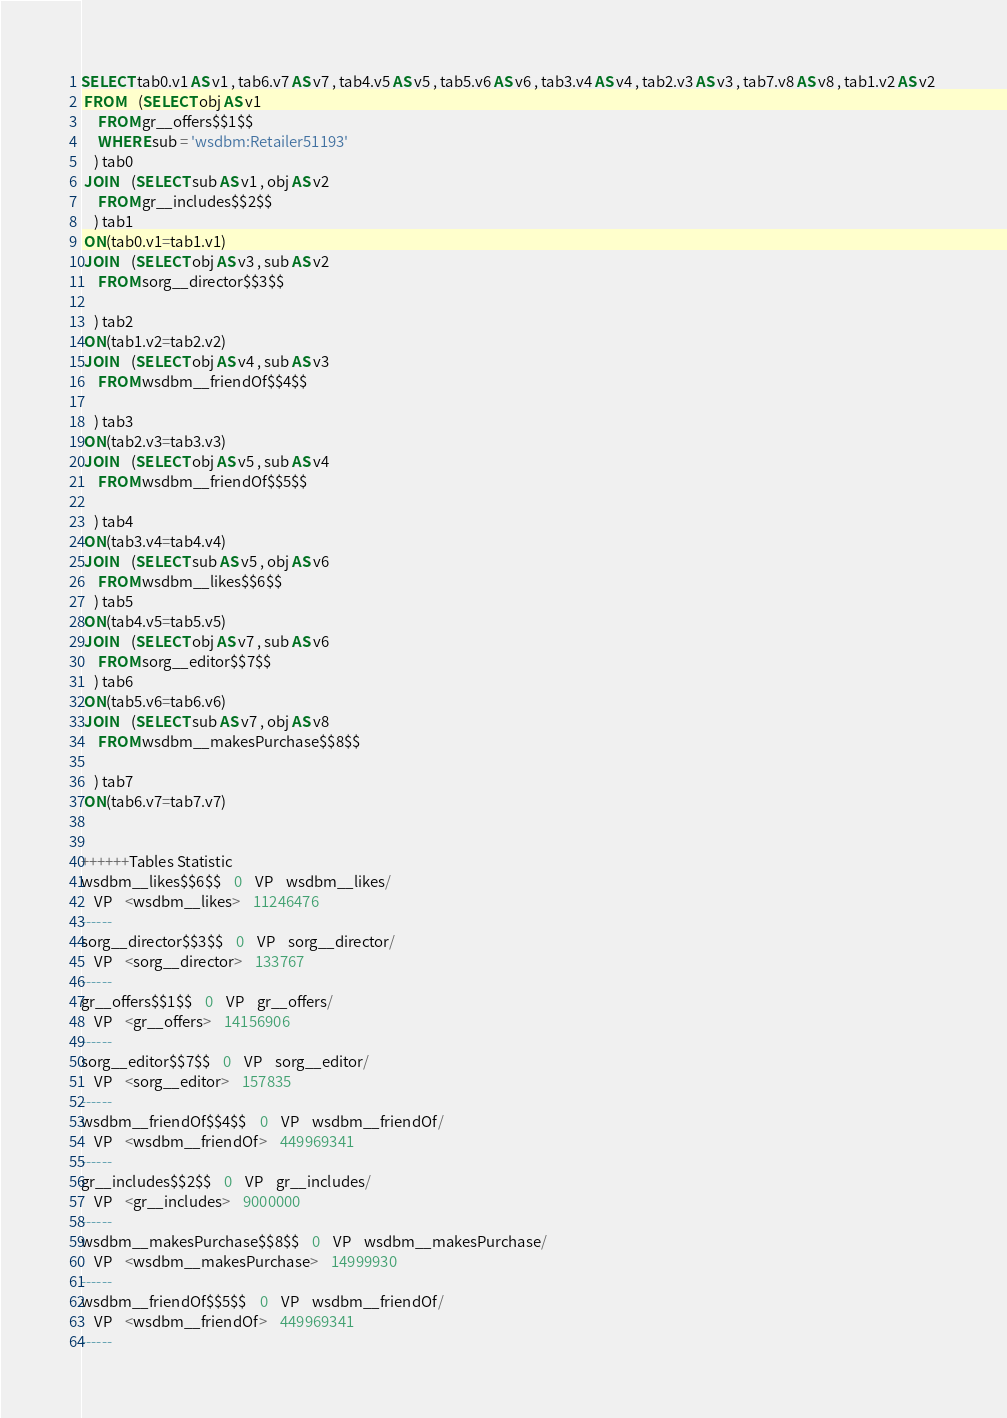<code> <loc_0><loc_0><loc_500><loc_500><_SQL_>SELECT tab0.v1 AS v1 , tab6.v7 AS v7 , tab4.v5 AS v5 , tab5.v6 AS v6 , tab3.v4 AS v4 , tab2.v3 AS v3 , tab7.v8 AS v8 , tab1.v2 AS v2 
 FROM    (SELECT obj AS v1 
	 FROM gr__offers$$1$$ 
	 WHERE sub = 'wsdbm:Retailer51193'
	) tab0
 JOIN    (SELECT sub AS v1 , obj AS v2 
	 FROM gr__includes$$2$$
	) tab1
 ON(tab0.v1=tab1.v1)
 JOIN    (SELECT obj AS v3 , sub AS v2 
	 FROM sorg__director$$3$$
	
	) tab2
 ON(tab1.v2=tab2.v2)
 JOIN    (SELECT obj AS v4 , sub AS v3 
	 FROM wsdbm__friendOf$$4$$
	
	) tab3
 ON(tab2.v3=tab3.v3)
 JOIN    (SELECT obj AS v5 , sub AS v4 
	 FROM wsdbm__friendOf$$5$$
	
	) tab4
 ON(tab3.v4=tab4.v4)
 JOIN    (SELECT sub AS v5 , obj AS v6 
	 FROM wsdbm__likes$$6$$
	) tab5
 ON(tab4.v5=tab5.v5)
 JOIN    (SELECT obj AS v7 , sub AS v6 
	 FROM sorg__editor$$7$$
	) tab6
 ON(tab5.v6=tab6.v6)
 JOIN    (SELECT sub AS v7 , obj AS v8 
	 FROM wsdbm__makesPurchase$$8$$
	
	) tab7
 ON(tab6.v7=tab7.v7)


++++++Tables Statistic
wsdbm__likes$$6$$	0	VP	wsdbm__likes/
	VP	<wsdbm__likes>	11246476
------
sorg__director$$3$$	0	VP	sorg__director/
	VP	<sorg__director>	133767
------
gr__offers$$1$$	0	VP	gr__offers/
	VP	<gr__offers>	14156906
------
sorg__editor$$7$$	0	VP	sorg__editor/
	VP	<sorg__editor>	157835
------
wsdbm__friendOf$$4$$	0	VP	wsdbm__friendOf/
	VP	<wsdbm__friendOf>	449969341
------
gr__includes$$2$$	0	VP	gr__includes/
	VP	<gr__includes>	9000000
------
wsdbm__makesPurchase$$8$$	0	VP	wsdbm__makesPurchase/
	VP	<wsdbm__makesPurchase>	14999930
------
wsdbm__friendOf$$5$$	0	VP	wsdbm__friendOf/
	VP	<wsdbm__friendOf>	449969341
------
</code> 